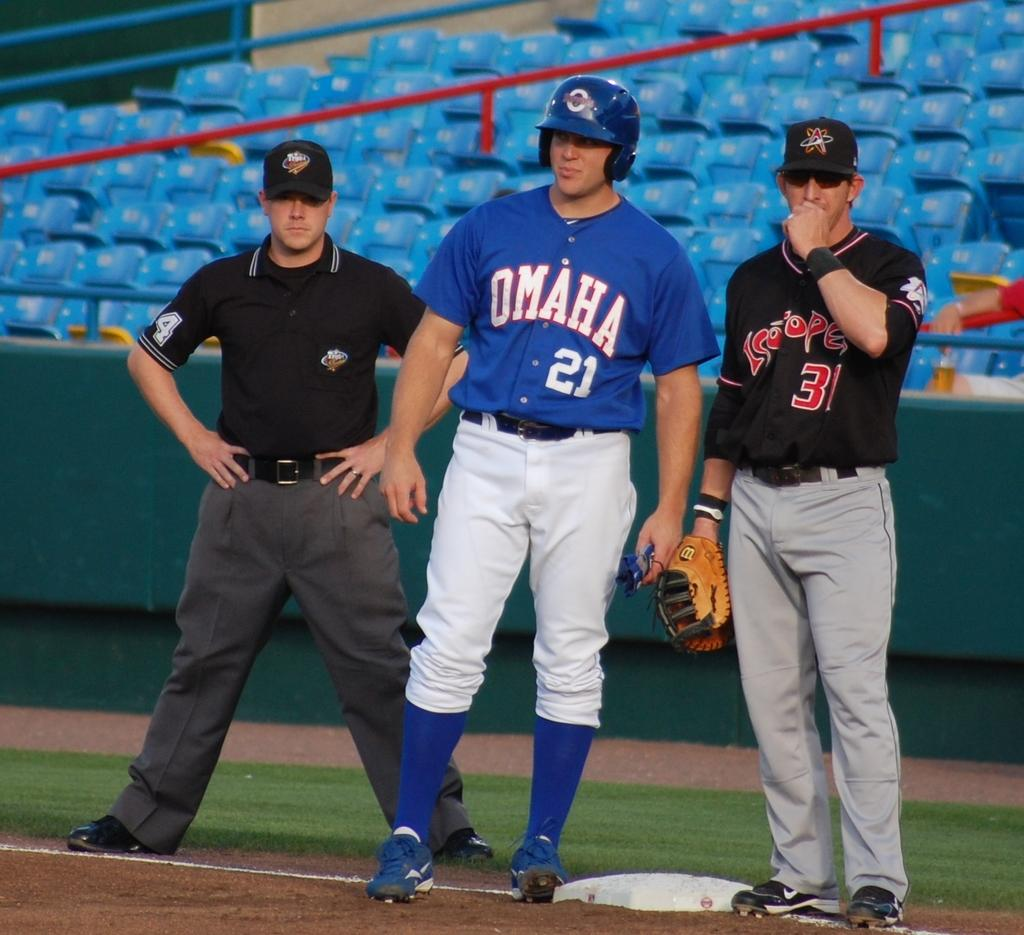<image>
Relay a brief, clear account of the picture shown. Omaha player number 21 waits on the base for a hit. 